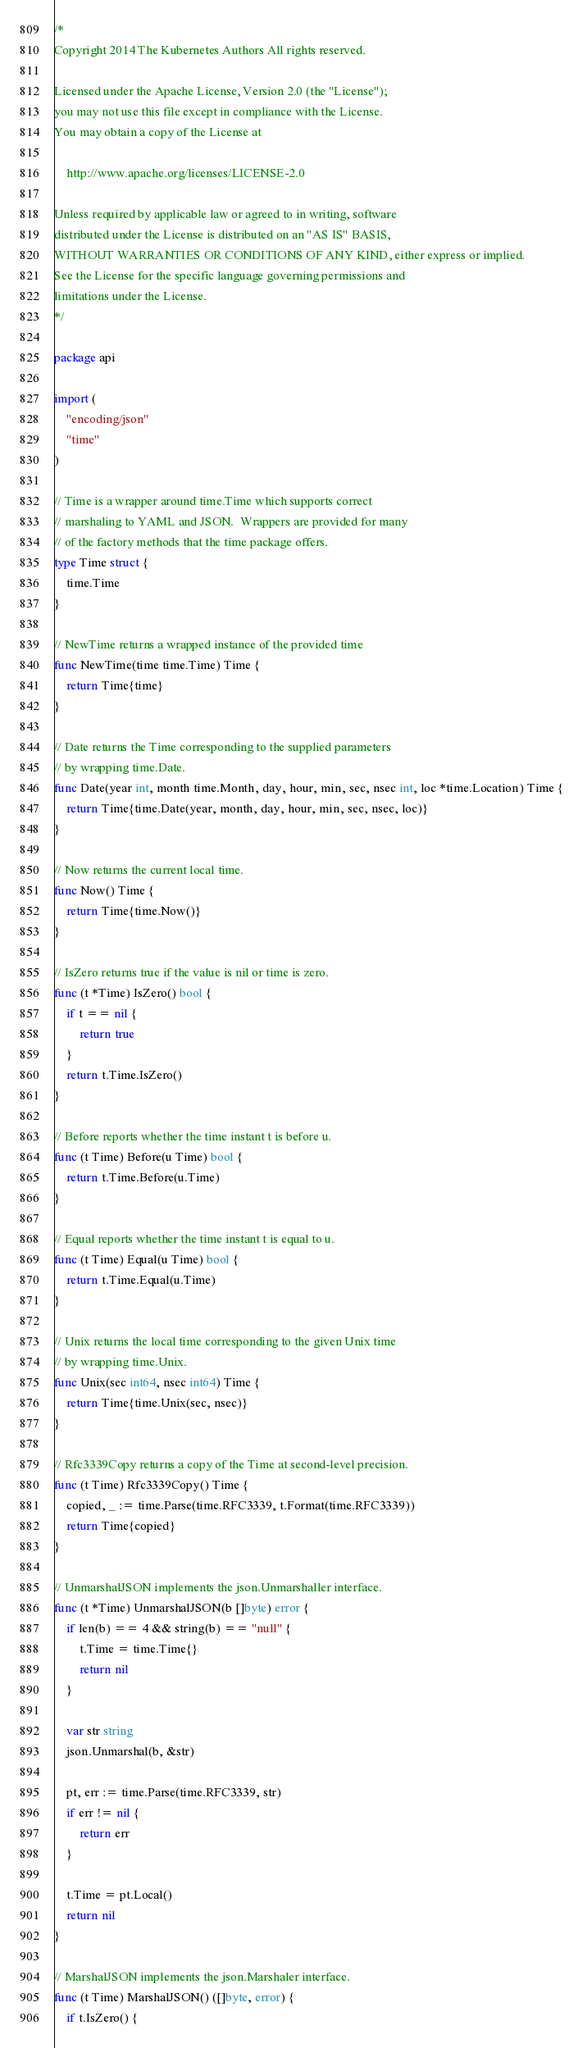Convert code to text. <code><loc_0><loc_0><loc_500><loc_500><_Go_>/*
Copyright 2014 The Kubernetes Authors All rights reserved.

Licensed under the Apache License, Version 2.0 (the "License");
you may not use this file except in compliance with the License.
You may obtain a copy of the License at

    http://www.apache.org/licenses/LICENSE-2.0

Unless required by applicable law or agreed to in writing, software
distributed under the License is distributed on an "AS IS" BASIS,
WITHOUT WARRANTIES OR CONDITIONS OF ANY KIND, either express or implied.
See the License for the specific language governing permissions and
limitations under the License.
*/

package api

import (
	"encoding/json"
	"time"
)

// Time is a wrapper around time.Time which supports correct
// marshaling to YAML and JSON.  Wrappers are provided for many
// of the factory methods that the time package offers.
type Time struct {
	time.Time
}

// NewTime returns a wrapped instance of the provided time
func NewTime(time time.Time) Time {
	return Time{time}
}

// Date returns the Time corresponding to the supplied parameters
// by wrapping time.Date.
func Date(year int, month time.Month, day, hour, min, sec, nsec int, loc *time.Location) Time {
	return Time{time.Date(year, month, day, hour, min, sec, nsec, loc)}
}

// Now returns the current local time.
func Now() Time {
	return Time{time.Now()}
}

// IsZero returns true if the value is nil or time is zero.
func (t *Time) IsZero() bool {
	if t == nil {
		return true
	}
	return t.Time.IsZero()
}

// Before reports whether the time instant t is before u.
func (t Time) Before(u Time) bool {
	return t.Time.Before(u.Time)
}

// Equal reports whether the time instant t is equal to u.
func (t Time) Equal(u Time) bool {
	return t.Time.Equal(u.Time)
}

// Unix returns the local time corresponding to the given Unix time
// by wrapping time.Unix.
func Unix(sec int64, nsec int64) Time {
	return Time{time.Unix(sec, nsec)}
}

// Rfc3339Copy returns a copy of the Time at second-level precision.
func (t Time) Rfc3339Copy() Time {
	copied, _ := time.Parse(time.RFC3339, t.Format(time.RFC3339))
	return Time{copied}
}

// UnmarshalJSON implements the json.Unmarshaller interface.
func (t *Time) UnmarshalJSON(b []byte) error {
	if len(b) == 4 && string(b) == "null" {
		t.Time = time.Time{}
		return nil
	}

	var str string
	json.Unmarshal(b, &str)

	pt, err := time.Parse(time.RFC3339, str)
	if err != nil {
		return err
	}

	t.Time = pt.Local()
	return nil
}

// MarshalJSON implements the json.Marshaler interface.
func (t Time) MarshalJSON() ([]byte, error) {
	if t.IsZero() {</code> 